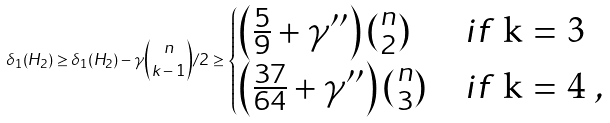Convert formula to latex. <formula><loc_0><loc_0><loc_500><loc_500>\delta _ { 1 } ( H _ { 2 } ) \geq \delta _ { 1 } ( H _ { 2 } ) - \gamma \binom { n } { k - 1 } / 2 \geq \begin{cases} \left ( \frac { 5 } { 9 } + \gamma ^ { \prime \prime } \right ) \binom { n } 2 & i f $ k = 3 $ \\ \left ( \frac { 3 7 } { 6 4 } + \gamma ^ { \prime \prime } \right ) \binom { n } 3 & i f $ k = 4 $ , \end{cases}</formula> 